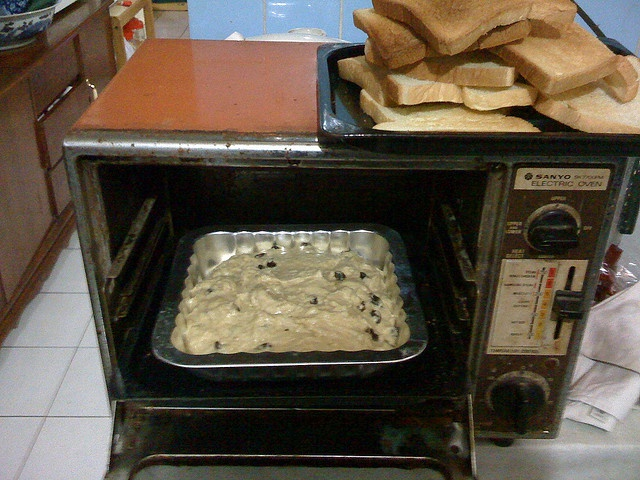Describe the objects in this image and their specific colors. I can see a oven in darkblue, black, tan, and gray tones in this image. 